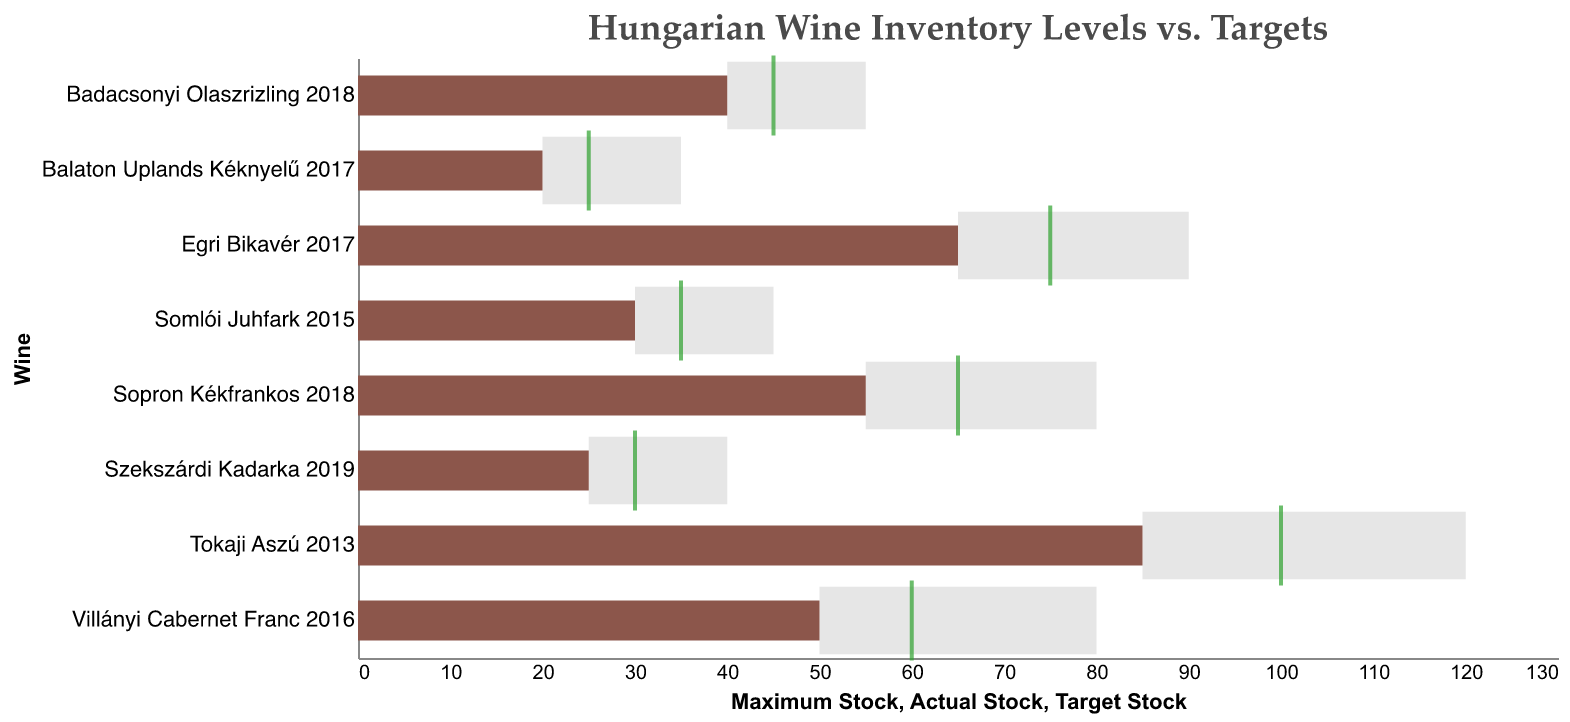What is the title of the figure? The title of the figure is usually positioned at the top and is set in a larger font size compared to other text elements to stand out. In the provided code, the title is specified as "Hungarian Wine Inventory Levels vs. Targets".
Answer: Hungarian Wine Inventory Levels vs. Targets How many types of Hungarian wines are shown? To determine the number of wine types, you can count the distinct wine labels displayed along the y-axis of the chart. Each label represents a different type of Hungarian wine.
Answer: 8 Which wine has the highest actual stock level? By examining the bars representing the actual stock levels, the longest bar indicates the highest actual stock. In this case, Tokaji Aszú 2013 has the longest bar.
Answer: Tokaji Aszú 2013 Is the actual stock level of Badacsonyi Olaszrizling 2018 higher, lower, or equal to its target stock level? The actual stock level of Badacsonyi Olaszrizling 2018 is represented by a bar. The target stock level is indicated by a green tick mark. Comparing the two visually, the bar ends before reaching the tick mark, indicating it is lower.
Answer: Lower Which wine has the biggest gap between its actual stock and target stock levels? To find the biggest gap, measure the distance between the end of the actual stock bar and the green tick mark for each wine. Tokaji Aszú 2013 has the largest gap, as its actual stock is 85 while its target stock is 100, resulting in a gap of 15 units.
Answer: Tokaji Aszú 2013 What is the range of maximum stock levels across all wines? The range is calculated by subtracting the minimum maximum stock level from the maximum maximum stock level displayed on the chart. The minimum maximum stock level is Balaton Uplands Kéknyelű 2017 at 35, and the maximum is Tokaji Aszú 2013 at 120. Therefore, the range is 120 - 35.
Answer: 85 Which wines have met or exceeded their target stock levels? Check each wine's actual stock level bar and see if it meets or crosses the green tick mark (target stock level). None of the wines have actual stock levels that meet or exceed their target levels.
Answer: None How much more stock is needed for Egri Bikavér 2017 to reach its target? The target stock for Egri Bikavér 2017 is 75 and the actual stock is 65. The difference between these values (75 - 65) gives the additional stock needed.
Answer: 10 Which wine has the smallest gap between its actual stock and target stock levels? To find the smallest gap, compare the distance between the end of the actual stock bar and the green tick mark for each wine. Balaton Uplands Kéknyelű 2017 has the smallest gap, as its actual stock is 20 while its target stock is 25, resulting in a gap of 5 units.
Answer: Balaton Uplands Kéknyelű 2017 